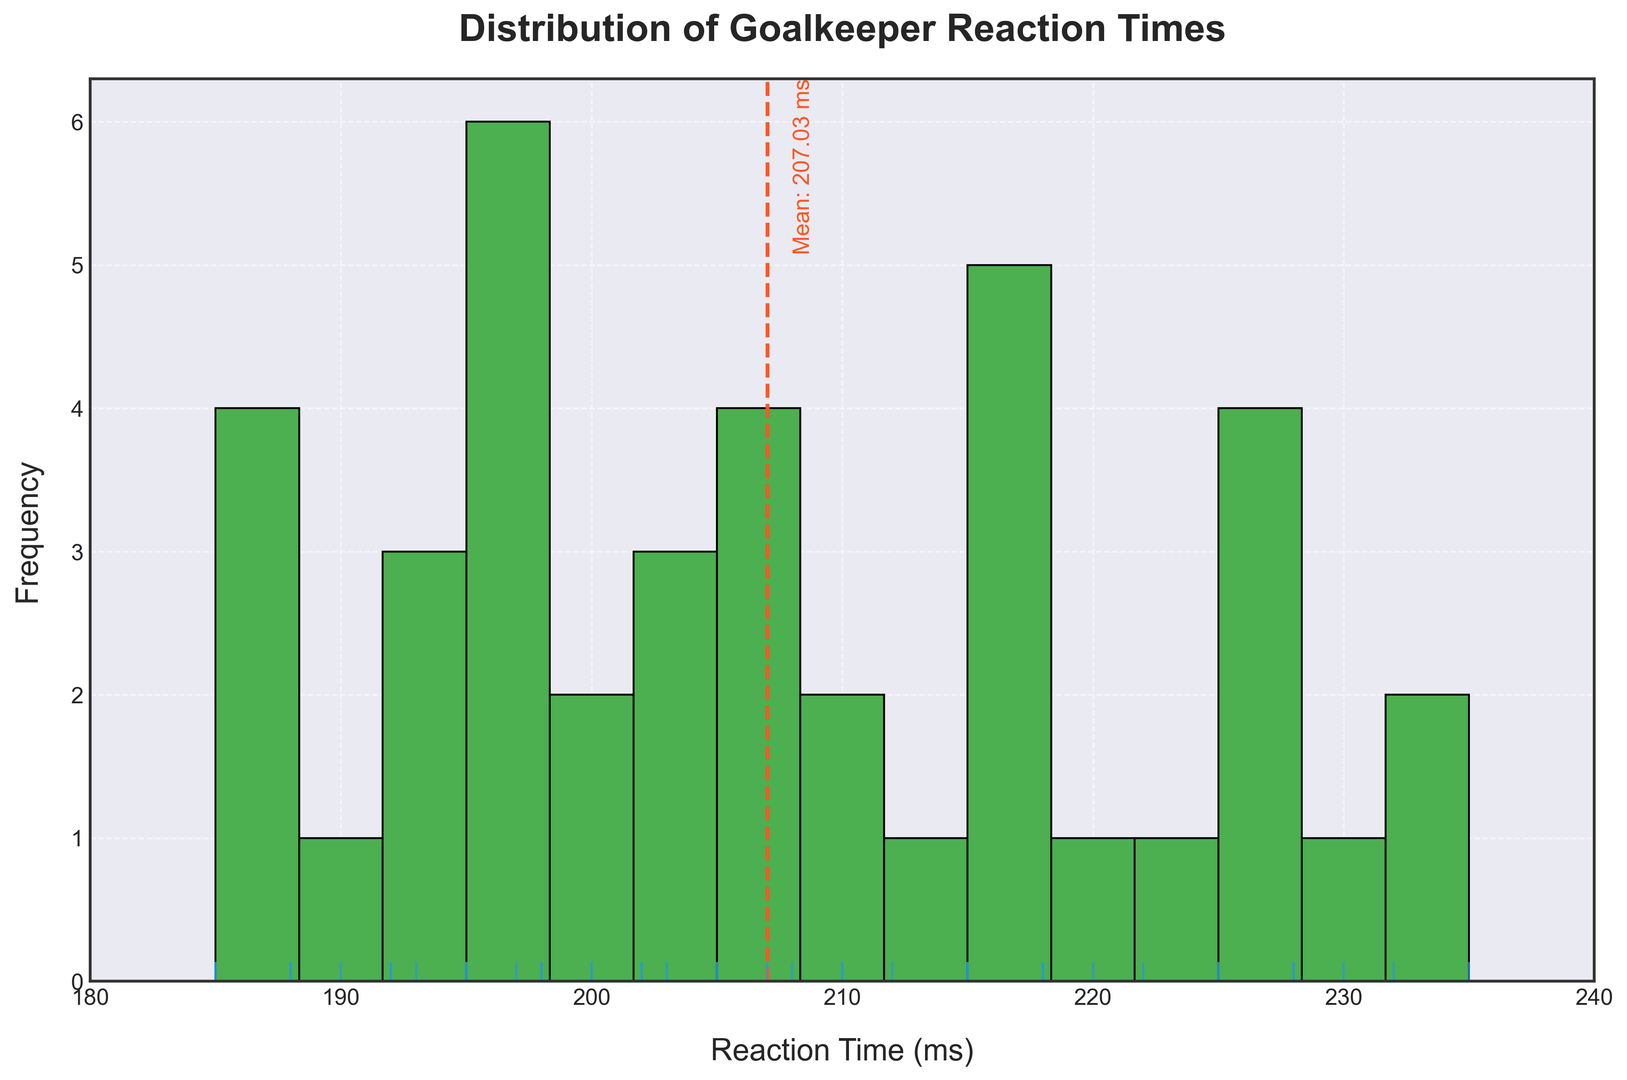What's the average reaction time of the goalkeepers? To find this, we add up all the reaction times and divide by the number of goalkeepers. The sum of reaction times is 8200 ms, and there are 40 goalkeepers. So, the average is 8200 / 40 = 205 ms.
Answer: 205 ms In which range is the most frequent reaction time? By observing the histogram, the highest bar indicates the most frequent reaction time range. This range is around 195-205 ms.
Answer: 195-205 ms How does the mean reaction time compare to the most frequent range? From the histogram, the mean reaction time is indicated by a dashed line at around 205 ms. The most frequent range is 195-205 ms. Both are very close, indicating that the distribution is centered around the mean.
Answer: Very close Is there a reaction time that appears significantly less frequently than others? The histogram shows some bins with shorter bars. The range between 225-240 ms has the lowest frequency, showing this reaction time appears less frequently.
Answer: 225-240 ms How many goalkeepers have a reaction time less than 190 ms? By examining the histogram, we identify the bin for the range 185-190 ms. The frequency can be approximated by looking at the height of the bars. Only a couple of goalkeepers fall into this range.
Answer: 2 Which goalkeeper reaction time is the highest? The rightmost edge of the histogram indicates the highest recorded reaction time. From the data: 235 ms.
Answer: 235 ms By how much does the highest reaction time exceed the mean reaction time? The highest reaction time is 235 ms, and the mean reaction time is 205 ms. The difference is 235 - 205 = 30 ms.
Answer: 30 ms Are there more goalkeepers with above-average reaction times or below-average reaction times? The average reaction time is 205 ms. By counting the bins to the right and left of this value and comparing, more goalkeepers are below-average.
Answer: Below-average What's the range of reaction times covered on this histogram? The x-axis limits show the range from 180 ms (leftmost) to 240 ms (rightmost).
Answer: 180-240 ms Which range has the second most frequent reaction times? After identifying the most frequent range (195-205 ms), look for the next highest bar. The second most frequent range is 210-220 ms.
Answer: 210-220 ms 